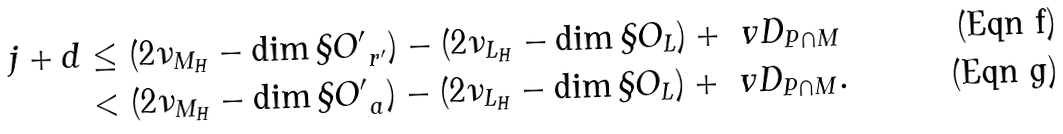<formula> <loc_0><loc_0><loc_500><loc_500>j + d & \leq ( 2 \nu _ { M _ { H } } - \dim \S O ^ { \prime } _ { \ r ^ { \prime } } ) - ( 2 \nu _ { L _ { H } } - \dim \S O _ { L } ) + \ v D _ { P \cap M } \\ & < ( 2 \nu _ { M _ { H } } - \dim \S O ^ { \prime } _ { \ a } ) - ( 2 \nu _ { L _ { H } } - \dim \S O _ { L } ) + \ v D _ { P \cap M } .</formula> 